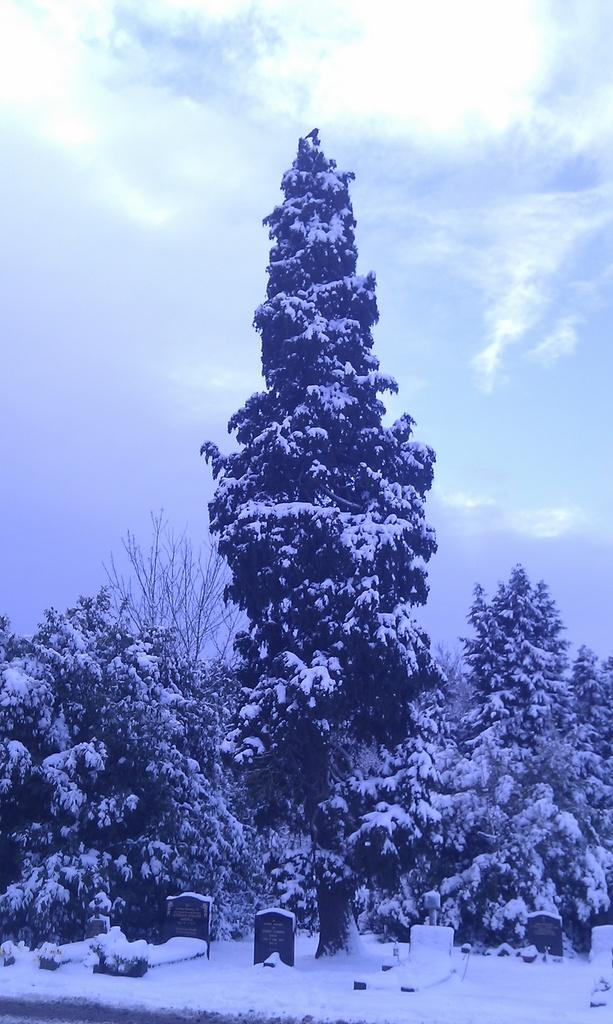What is the main feature of the landscape in the image? There are trees covered with snow in the image. What can be found at the bottom of the image? There are cemeteries at the bottom of the image. What is the condition of the ground in the image? Snow is present at the bottom of the image. What is visible in the background of the image? The sky is visible in the background of the image. What type of steel is used to construct the needles in the image? There are no needles present in the image; it features snow-covered trees and cemeteries. What is the tendency of the snow to melt in the image? The image does not provide information about the snow's tendency to melt; it only shows the snow as it currently appears. 